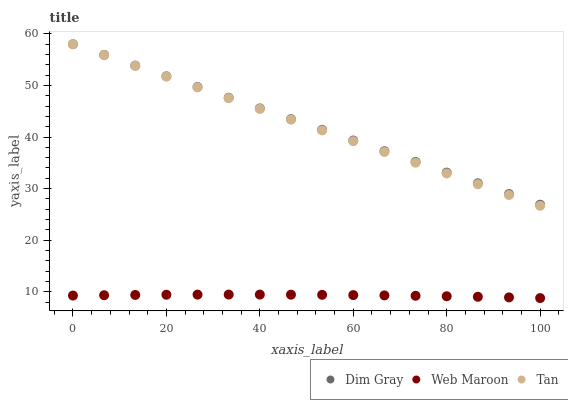Does Web Maroon have the minimum area under the curve?
Answer yes or no. Yes. Does Dim Gray have the maximum area under the curve?
Answer yes or no. Yes. Does Dim Gray have the minimum area under the curve?
Answer yes or no. No. Does Web Maroon have the maximum area under the curve?
Answer yes or no. No. Is Dim Gray the smoothest?
Answer yes or no. Yes. Is Web Maroon the roughest?
Answer yes or no. Yes. Is Web Maroon the smoothest?
Answer yes or no. No. Is Dim Gray the roughest?
Answer yes or no. No. Does Web Maroon have the lowest value?
Answer yes or no. Yes. Does Dim Gray have the lowest value?
Answer yes or no. No. Does Dim Gray have the highest value?
Answer yes or no. Yes. Does Web Maroon have the highest value?
Answer yes or no. No. Is Web Maroon less than Dim Gray?
Answer yes or no. Yes. Is Dim Gray greater than Web Maroon?
Answer yes or no. Yes. Does Dim Gray intersect Tan?
Answer yes or no. Yes. Is Dim Gray less than Tan?
Answer yes or no. No. Is Dim Gray greater than Tan?
Answer yes or no. No. Does Web Maroon intersect Dim Gray?
Answer yes or no. No. 